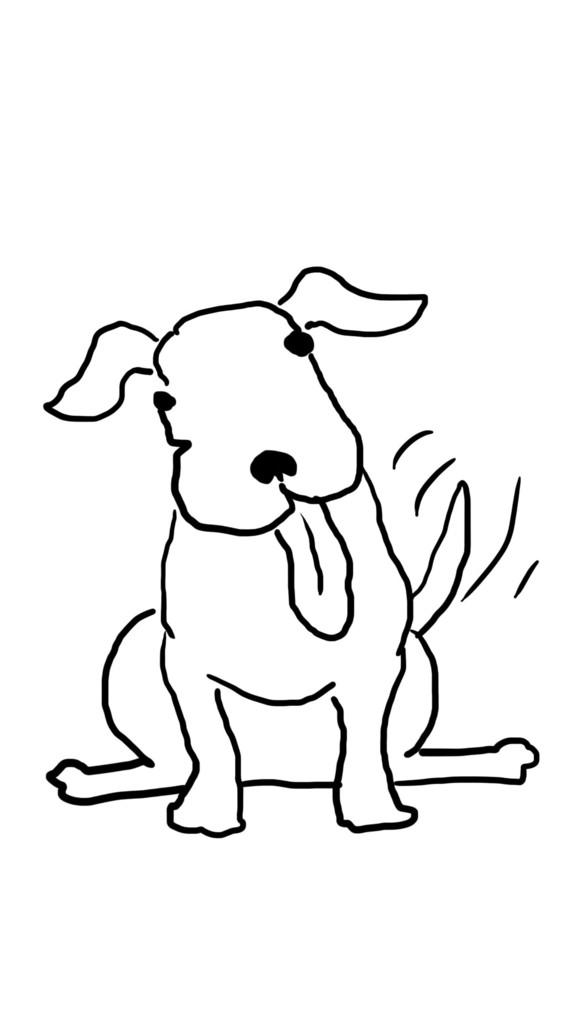What is depicted in the image? There is a drawing of a dog in the image. Does the dog in the image have a conversation with the artist? There is no indication in the image that the dog is talking or having a conversation with the artist, as it is a drawing and not a living dog. 